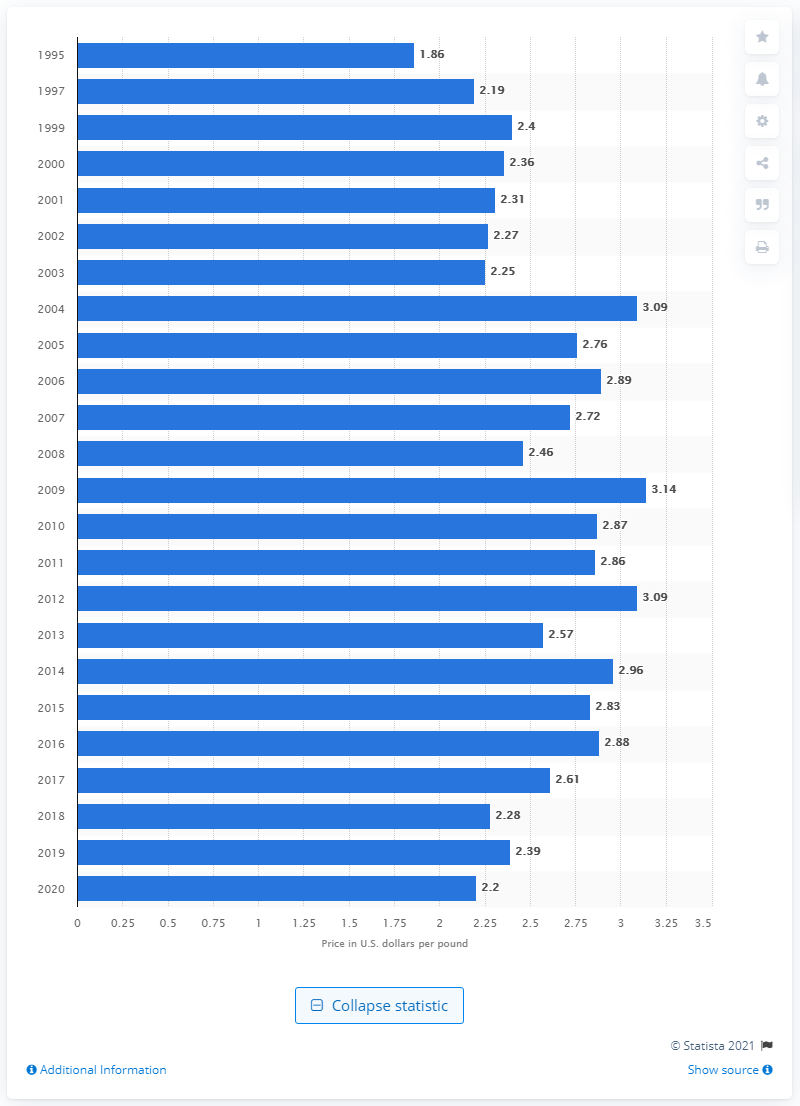Specify some key components in this picture. In 2009, the price per pound of seedless grapes was 3.14... The cost of one pound of seedless grapes in the United States in 2020 was approximately $2.20. 